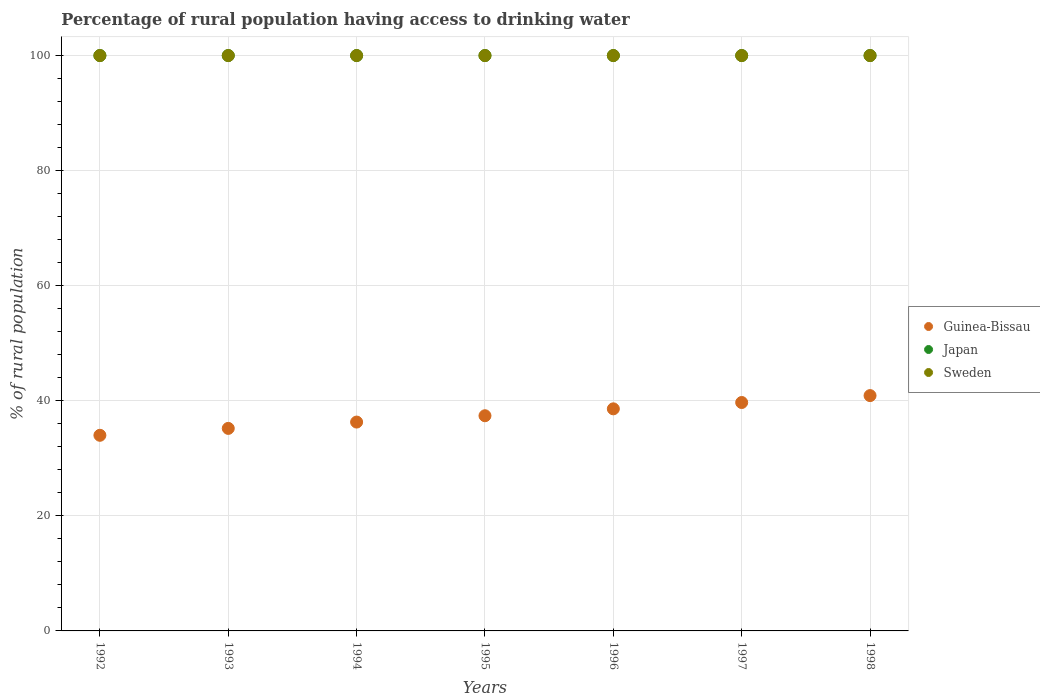How many different coloured dotlines are there?
Ensure brevity in your answer.  3. Is the number of dotlines equal to the number of legend labels?
Your answer should be very brief. Yes. What is the percentage of rural population having access to drinking water in Guinea-Bissau in 1994?
Your response must be concise. 36.3. Across all years, what is the maximum percentage of rural population having access to drinking water in Guinea-Bissau?
Ensure brevity in your answer.  40.9. Across all years, what is the minimum percentage of rural population having access to drinking water in Japan?
Your answer should be compact. 100. In which year was the percentage of rural population having access to drinking water in Guinea-Bissau maximum?
Your response must be concise. 1998. What is the total percentage of rural population having access to drinking water in Sweden in the graph?
Make the answer very short. 700. What is the difference between the percentage of rural population having access to drinking water in Guinea-Bissau in 1997 and that in 1998?
Your answer should be very brief. -1.2. What is the difference between the percentage of rural population having access to drinking water in Japan in 1995 and the percentage of rural population having access to drinking water in Sweden in 1997?
Make the answer very short. 0. What is the average percentage of rural population having access to drinking water in Japan per year?
Offer a very short reply. 100. In the year 1997, what is the difference between the percentage of rural population having access to drinking water in Japan and percentage of rural population having access to drinking water in Sweden?
Your answer should be compact. 0. What is the ratio of the percentage of rural population having access to drinking water in Guinea-Bissau in 1995 to that in 1997?
Your answer should be compact. 0.94. What is the difference between the highest and the second highest percentage of rural population having access to drinking water in Guinea-Bissau?
Offer a terse response. 1.2. What is the difference between the highest and the lowest percentage of rural population having access to drinking water in Sweden?
Ensure brevity in your answer.  0. Does the percentage of rural population having access to drinking water in Guinea-Bissau monotonically increase over the years?
Give a very brief answer. Yes. Is the percentage of rural population having access to drinking water in Guinea-Bissau strictly greater than the percentage of rural population having access to drinking water in Sweden over the years?
Offer a very short reply. No. How many years are there in the graph?
Provide a succinct answer. 7. What is the difference between two consecutive major ticks on the Y-axis?
Keep it short and to the point. 20. Does the graph contain any zero values?
Offer a terse response. No. Does the graph contain grids?
Offer a very short reply. Yes. What is the title of the graph?
Give a very brief answer. Percentage of rural population having access to drinking water. What is the label or title of the Y-axis?
Provide a succinct answer. % of rural population. What is the % of rural population in Sweden in 1992?
Ensure brevity in your answer.  100. What is the % of rural population of Guinea-Bissau in 1993?
Offer a terse response. 35.2. What is the % of rural population in Guinea-Bissau in 1994?
Offer a terse response. 36.3. What is the % of rural population in Japan in 1994?
Keep it short and to the point. 100. What is the % of rural population of Guinea-Bissau in 1995?
Give a very brief answer. 37.4. What is the % of rural population in Japan in 1995?
Keep it short and to the point. 100. What is the % of rural population in Guinea-Bissau in 1996?
Your answer should be compact. 38.6. What is the % of rural population of Guinea-Bissau in 1997?
Provide a short and direct response. 39.7. What is the % of rural population of Japan in 1997?
Your answer should be very brief. 100. What is the % of rural population of Guinea-Bissau in 1998?
Give a very brief answer. 40.9. Across all years, what is the maximum % of rural population in Guinea-Bissau?
Provide a succinct answer. 40.9. Across all years, what is the maximum % of rural population of Sweden?
Provide a short and direct response. 100. Across all years, what is the minimum % of rural population in Japan?
Offer a very short reply. 100. Across all years, what is the minimum % of rural population in Sweden?
Your answer should be compact. 100. What is the total % of rural population in Guinea-Bissau in the graph?
Give a very brief answer. 262.1. What is the total % of rural population of Japan in the graph?
Offer a very short reply. 700. What is the total % of rural population in Sweden in the graph?
Make the answer very short. 700. What is the difference between the % of rural population of Sweden in 1992 and that in 1993?
Your answer should be compact. 0. What is the difference between the % of rural population of Guinea-Bissau in 1992 and that in 1994?
Provide a short and direct response. -2.3. What is the difference between the % of rural population of Japan in 1992 and that in 1994?
Make the answer very short. 0. What is the difference between the % of rural population in Sweden in 1992 and that in 1994?
Ensure brevity in your answer.  0. What is the difference between the % of rural population in Guinea-Bissau in 1992 and that in 1997?
Your response must be concise. -5.7. What is the difference between the % of rural population in Guinea-Bissau in 1993 and that in 1994?
Give a very brief answer. -1.1. What is the difference between the % of rural population of Sweden in 1993 and that in 1995?
Your answer should be compact. 0. What is the difference between the % of rural population of Guinea-Bissau in 1993 and that in 1996?
Your answer should be very brief. -3.4. What is the difference between the % of rural population of Japan in 1993 and that in 1996?
Provide a short and direct response. 0. What is the difference between the % of rural population in Guinea-Bissau in 1993 and that in 1998?
Offer a very short reply. -5.7. What is the difference between the % of rural population of Japan in 1993 and that in 1998?
Offer a terse response. 0. What is the difference between the % of rural population of Guinea-Bissau in 1994 and that in 1996?
Make the answer very short. -2.3. What is the difference between the % of rural population in Japan in 1994 and that in 1996?
Your response must be concise. 0. What is the difference between the % of rural population in Guinea-Bissau in 1994 and that in 1997?
Your answer should be very brief. -3.4. What is the difference between the % of rural population of Japan in 1994 and that in 1997?
Your answer should be very brief. 0. What is the difference between the % of rural population in Guinea-Bissau in 1994 and that in 1998?
Make the answer very short. -4.6. What is the difference between the % of rural population of Guinea-Bissau in 1995 and that in 1996?
Make the answer very short. -1.2. What is the difference between the % of rural population in Japan in 1995 and that in 1996?
Your answer should be compact. 0. What is the difference between the % of rural population in Sweden in 1995 and that in 1996?
Provide a succinct answer. 0. What is the difference between the % of rural population in Guinea-Bissau in 1995 and that in 1997?
Keep it short and to the point. -2.3. What is the difference between the % of rural population in Japan in 1995 and that in 1997?
Provide a succinct answer. 0. What is the difference between the % of rural population in Guinea-Bissau in 1995 and that in 1998?
Offer a very short reply. -3.5. What is the difference between the % of rural population in Japan in 1996 and that in 1997?
Give a very brief answer. 0. What is the difference between the % of rural population of Guinea-Bissau in 1996 and that in 1998?
Keep it short and to the point. -2.3. What is the difference between the % of rural population in Japan in 1996 and that in 1998?
Offer a very short reply. 0. What is the difference between the % of rural population of Sweden in 1997 and that in 1998?
Ensure brevity in your answer.  0. What is the difference between the % of rural population in Guinea-Bissau in 1992 and the % of rural population in Japan in 1993?
Your answer should be compact. -66. What is the difference between the % of rural population in Guinea-Bissau in 1992 and the % of rural population in Sweden in 1993?
Make the answer very short. -66. What is the difference between the % of rural population of Japan in 1992 and the % of rural population of Sweden in 1993?
Your answer should be compact. 0. What is the difference between the % of rural population in Guinea-Bissau in 1992 and the % of rural population in Japan in 1994?
Your response must be concise. -66. What is the difference between the % of rural population of Guinea-Bissau in 1992 and the % of rural population of Sweden in 1994?
Keep it short and to the point. -66. What is the difference between the % of rural population in Japan in 1992 and the % of rural population in Sweden in 1994?
Provide a succinct answer. 0. What is the difference between the % of rural population in Guinea-Bissau in 1992 and the % of rural population in Japan in 1995?
Your answer should be compact. -66. What is the difference between the % of rural population of Guinea-Bissau in 1992 and the % of rural population of Sweden in 1995?
Your response must be concise. -66. What is the difference between the % of rural population of Japan in 1992 and the % of rural population of Sweden in 1995?
Ensure brevity in your answer.  0. What is the difference between the % of rural population in Guinea-Bissau in 1992 and the % of rural population in Japan in 1996?
Offer a very short reply. -66. What is the difference between the % of rural population in Guinea-Bissau in 1992 and the % of rural population in Sweden in 1996?
Keep it short and to the point. -66. What is the difference between the % of rural population in Japan in 1992 and the % of rural population in Sweden in 1996?
Ensure brevity in your answer.  0. What is the difference between the % of rural population of Guinea-Bissau in 1992 and the % of rural population of Japan in 1997?
Ensure brevity in your answer.  -66. What is the difference between the % of rural population in Guinea-Bissau in 1992 and the % of rural population in Sweden in 1997?
Keep it short and to the point. -66. What is the difference between the % of rural population in Guinea-Bissau in 1992 and the % of rural population in Japan in 1998?
Your answer should be very brief. -66. What is the difference between the % of rural population in Guinea-Bissau in 1992 and the % of rural population in Sweden in 1998?
Your answer should be compact. -66. What is the difference between the % of rural population in Japan in 1992 and the % of rural population in Sweden in 1998?
Your answer should be very brief. 0. What is the difference between the % of rural population of Guinea-Bissau in 1993 and the % of rural population of Japan in 1994?
Your answer should be compact. -64.8. What is the difference between the % of rural population of Guinea-Bissau in 1993 and the % of rural population of Sweden in 1994?
Your response must be concise. -64.8. What is the difference between the % of rural population in Japan in 1993 and the % of rural population in Sweden in 1994?
Your response must be concise. 0. What is the difference between the % of rural population in Guinea-Bissau in 1993 and the % of rural population in Japan in 1995?
Offer a terse response. -64.8. What is the difference between the % of rural population in Guinea-Bissau in 1993 and the % of rural population in Sweden in 1995?
Provide a short and direct response. -64.8. What is the difference between the % of rural population of Guinea-Bissau in 1993 and the % of rural population of Japan in 1996?
Offer a very short reply. -64.8. What is the difference between the % of rural population in Guinea-Bissau in 1993 and the % of rural population in Sweden in 1996?
Make the answer very short. -64.8. What is the difference between the % of rural population in Guinea-Bissau in 1993 and the % of rural population in Japan in 1997?
Offer a very short reply. -64.8. What is the difference between the % of rural population in Guinea-Bissau in 1993 and the % of rural population in Sweden in 1997?
Give a very brief answer. -64.8. What is the difference between the % of rural population of Guinea-Bissau in 1993 and the % of rural population of Japan in 1998?
Keep it short and to the point. -64.8. What is the difference between the % of rural population of Guinea-Bissau in 1993 and the % of rural population of Sweden in 1998?
Your answer should be very brief. -64.8. What is the difference between the % of rural population of Japan in 1993 and the % of rural population of Sweden in 1998?
Keep it short and to the point. 0. What is the difference between the % of rural population of Guinea-Bissau in 1994 and the % of rural population of Japan in 1995?
Give a very brief answer. -63.7. What is the difference between the % of rural population of Guinea-Bissau in 1994 and the % of rural population of Sweden in 1995?
Your answer should be very brief. -63.7. What is the difference between the % of rural population in Guinea-Bissau in 1994 and the % of rural population in Japan in 1996?
Your answer should be very brief. -63.7. What is the difference between the % of rural population in Guinea-Bissau in 1994 and the % of rural population in Sweden in 1996?
Provide a short and direct response. -63.7. What is the difference between the % of rural population in Japan in 1994 and the % of rural population in Sweden in 1996?
Offer a very short reply. 0. What is the difference between the % of rural population of Guinea-Bissau in 1994 and the % of rural population of Japan in 1997?
Your answer should be very brief. -63.7. What is the difference between the % of rural population of Guinea-Bissau in 1994 and the % of rural population of Sweden in 1997?
Make the answer very short. -63.7. What is the difference between the % of rural population in Guinea-Bissau in 1994 and the % of rural population in Japan in 1998?
Provide a short and direct response. -63.7. What is the difference between the % of rural population of Guinea-Bissau in 1994 and the % of rural population of Sweden in 1998?
Give a very brief answer. -63.7. What is the difference between the % of rural population in Guinea-Bissau in 1995 and the % of rural population in Japan in 1996?
Provide a succinct answer. -62.6. What is the difference between the % of rural population of Guinea-Bissau in 1995 and the % of rural population of Sweden in 1996?
Provide a short and direct response. -62.6. What is the difference between the % of rural population in Japan in 1995 and the % of rural population in Sweden in 1996?
Offer a terse response. 0. What is the difference between the % of rural population in Guinea-Bissau in 1995 and the % of rural population in Japan in 1997?
Ensure brevity in your answer.  -62.6. What is the difference between the % of rural population in Guinea-Bissau in 1995 and the % of rural population in Sweden in 1997?
Your response must be concise. -62.6. What is the difference between the % of rural population of Japan in 1995 and the % of rural population of Sweden in 1997?
Provide a short and direct response. 0. What is the difference between the % of rural population of Guinea-Bissau in 1995 and the % of rural population of Japan in 1998?
Ensure brevity in your answer.  -62.6. What is the difference between the % of rural population of Guinea-Bissau in 1995 and the % of rural population of Sweden in 1998?
Your answer should be very brief. -62.6. What is the difference between the % of rural population in Japan in 1995 and the % of rural population in Sweden in 1998?
Keep it short and to the point. 0. What is the difference between the % of rural population of Guinea-Bissau in 1996 and the % of rural population of Japan in 1997?
Your response must be concise. -61.4. What is the difference between the % of rural population in Guinea-Bissau in 1996 and the % of rural population in Sweden in 1997?
Make the answer very short. -61.4. What is the difference between the % of rural population in Japan in 1996 and the % of rural population in Sweden in 1997?
Give a very brief answer. 0. What is the difference between the % of rural population of Guinea-Bissau in 1996 and the % of rural population of Japan in 1998?
Your answer should be compact. -61.4. What is the difference between the % of rural population in Guinea-Bissau in 1996 and the % of rural population in Sweden in 1998?
Your response must be concise. -61.4. What is the difference between the % of rural population in Guinea-Bissau in 1997 and the % of rural population in Japan in 1998?
Give a very brief answer. -60.3. What is the difference between the % of rural population in Guinea-Bissau in 1997 and the % of rural population in Sweden in 1998?
Offer a terse response. -60.3. What is the average % of rural population of Guinea-Bissau per year?
Ensure brevity in your answer.  37.44. What is the average % of rural population of Japan per year?
Make the answer very short. 100. What is the average % of rural population in Sweden per year?
Your answer should be very brief. 100. In the year 1992, what is the difference between the % of rural population in Guinea-Bissau and % of rural population in Japan?
Your answer should be very brief. -66. In the year 1992, what is the difference between the % of rural population of Guinea-Bissau and % of rural population of Sweden?
Offer a terse response. -66. In the year 1993, what is the difference between the % of rural population in Guinea-Bissau and % of rural population in Japan?
Your response must be concise. -64.8. In the year 1993, what is the difference between the % of rural population of Guinea-Bissau and % of rural population of Sweden?
Give a very brief answer. -64.8. In the year 1994, what is the difference between the % of rural population in Guinea-Bissau and % of rural population in Japan?
Your response must be concise. -63.7. In the year 1994, what is the difference between the % of rural population of Guinea-Bissau and % of rural population of Sweden?
Offer a terse response. -63.7. In the year 1995, what is the difference between the % of rural population in Guinea-Bissau and % of rural population in Japan?
Provide a succinct answer. -62.6. In the year 1995, what is the difference between the % of rural population of Guinea-Bissau and % of rural population of Sweden?
Your response must be concise. -62.6. In the year 1995, what is the difference between the % of rural population of Japan and % of rural population of Sweden?
Make the answer very short. 0. In the year 1996, what is the difference between the % of rural population in Guinea-Bissau and % of rural population in Japan?
Your answer should be very brief. -61.4. In the year 1996, what is the difference between the % of rural population in Guinea-Bissau and % of rural population in Sweden?
Your answer should be compact. -61.4. In the year 1996, what is the difference between the % of rural population in Japan and % of rural population in Sweden?
Offer a terse response. 0. In the year 1997, what is the difference between the % of rural population of Guinea-Bissau and % of rural population of Japan?
Provide a succinct answer. -60.3. In the year 1997, what is the difference between the % of rural population in Guinea-Bissau and % of rural population in Sweden?
Offer a terse response. -60.3. In the year 1998, what is the difference between the % of rural population in Guinea-Bissau and % of rural population in Japan?
Offer a very short reply. -59.1. In the year 1998, what is the difference between the % of rural population of Guinea-Bissau and % of rural population of Sweden?
Give a very brief answer. -59.1. In the year 1998, what is the difference between the % of rural population in Japan and % of rural population in Sweden?
Offer a terse response. 0. What is the ratio of the % of rural population of Guinea-Bissau in 1992 to that in 1993?
Make the answer very short. 0.97. What is the ratio of the % of rural population of Japan in 1992 to that in 1993?
Your answer should be compact. 1. What is the ratio of the % of rural population of Sweden in 1992 to that in 1993?
Provide a short and direct response. 1. What is the ratio of the % of rural population of Guinea-Bissau in 1992 to that in 1994?
Provide a short and direct response. 0.94. What is the ratio of the % of rural population of Sweden in 1992 to that in 1994?
Offer a very short reply. 1. What is the ratio of the % of rural population in Japan in 1992 to that in 1995?
Your answer should be very brief. 1. What is the ratio of the % of rural population of Sweden in 1992 to that in 1995?
Offer a terse response. 1. What is the ratio of the % of rural population of Guinea-Bissau in 1992 to that in 1996?
Make the answer very short. 0.88. What is the ratio of the % of rural population of Japan in 1992 to that in 1996?
Your response must be concise. 1. What is the ratio of the % of rural population of Guinea-Bissau in 1992 to that in 1997?
Give a very brief answer. 0.86. What is the ratio of the % of rural population in Japan in 1992 to that in 1997?
Offer a terse response. 1. What is the ratio of the % of rural population of Guinea-Bissau in 1992 to that in 1998?
Provide a short and direct response. 0.83. What is the ratio of the % of rural population of Sweden in 1992 to that in 1998?
Provide a short and direct response. 1. What is the ratio of the % of rural population in Guinea-Bissau in 1993 to that in 1994?
Your response must be concise. 0.97. What is the ratio of the % of rural population of Japan in 1993 to that in 1994?
Provide a succinct answer. 1. What is the ratio of the % of rural population in Guinea-Bissau in 1993 to that in 1995?
Provide a succinct answer. 0.94. What is the ratio of the % of rural population in Sweden in 1993 to that in 1995?
Ensure brevity in your answer.  1. What is the ratio of the % of rural population of Guinea-Bissau in 1993 to that in 1996?
Provide a short and direct response. 0.91. What is the ratio of the % of rural population in Sweden in 1993 to that in 1996?
Your answer should be compact. 1. What is the ratio of the % of rural population of Guinea-Bissau in 1993 to that in 1997?
Make the answer very short. 0.89. What is the ratio of the % of rural population of Sweden in 1993 to that in 1997?
Ensure brevity in your answer.  1. What is the ratio of the % of rural population of Guinea-Bissau in 1993 to that in 1998?
Give a very brief answer. 0.86. What is the ratio of the % of rural population in Japan in 1993 to that in 1998?
Provide a succinct answer. 1. What is the ratio of the % of rural population of Sweden in 1993 to that in 1998?
Your answer should be compact. 1. What is the ratio of the % of rural population of Guinea-Bissau in 1994 to that in 1995?
Ensure brevity in your answer.  0.97. What is the ratio of the % of rural population of Japan in 1994 to that in 1995?
Your response must be concise. 1. What is the ratio of the % of rural population of Guinea-Bissau in 1994 to that in 1996?
Ensure brevity in your answer.  0.94. What is the ratio of the % of rural population of Japan in 1994 to that in 1996?
Make the answer very short. 1. What is the ratio of the % of rural population of Guinea-Bissau in 1994 to that in 1997?
Offer a terse response. 0.91. What is the ratio of the % of rural population in Guinea-Bissau in 1994 to that in 1998?
Make the answer very short. 0.89. What is the ratio of the % of rural population in Guinea-Bissau in 1995 to that in 1996?
Provide a succinct answer. 0.97. What is the ratio of the % of rural population of Sweden in 1995 to that in 1996?
Keep it short and to the point. 1. What is the ratio of the % of rural population of Guinea-Bissau in 1995 to that in 1997?
Provide a short and direct response. 0.94. What is the ratio of the % of rural population in Sweden in 1995 to that in 1997?
Give a very brief answer. 1. What is the ratio of the % of rural population in Guinea-Bissau in 1995 to that in 1998?
Your answer should be compact. 0.91. What is the ratio of the % of rural population of Sweden in 1995 to that in 1998?
Offer a terse response. 1. What is the ratio of the % of rural population in Guinea-Bissau in 1996 to that in 1997?
Your answer should be compact. 0.97. What is the ratio of the % of rural population of Guinea-Bissau in 1996 to that in 1998?
Give a very brief answer. 0.94. What is the ratio of the % of rural population in Sweden in 1996 to that in 1998?
Provide a succinct answer. 1. What is the ratio of the % of rural population of Guinea-Bissau in 1997 to that in 1998?
Offer a very short reply. 0.97. What is the ratio of the % of rural population in Japan in 1997 to that in 1998?
Your response must be concise. 1. What is the difference between the highest and the second highest % of rural population in Guinea-Bissau?
Your answer should be compact. 1.2. What is the difference between the highest and the lowest % of rural population of Guinea-Bissau?
Provide a short and direct response. 6.9. What is the difference between the highest and the lowest % of rural population in Japan?
Your response must be concise. 0. 